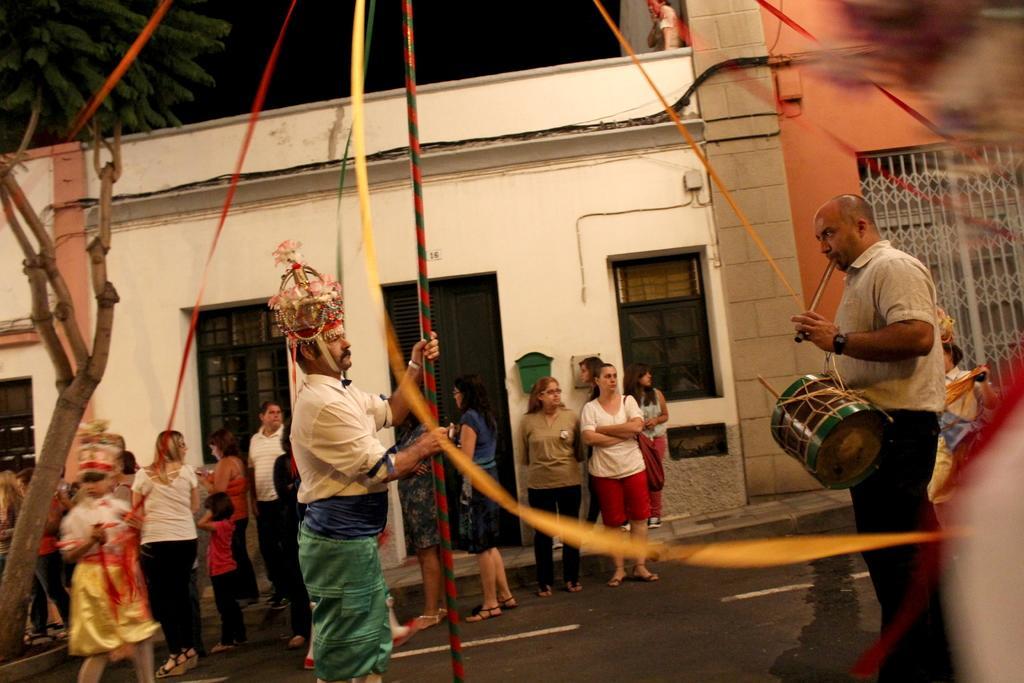How would you summarize this image in a sentence or two? In the picture we can find a two men standing, one man is holding a pole and other is holding a drum and playing it. In the background we can find some people are standing and watching. And we can also find the houses, doors, windows, gate, sky and tree. 